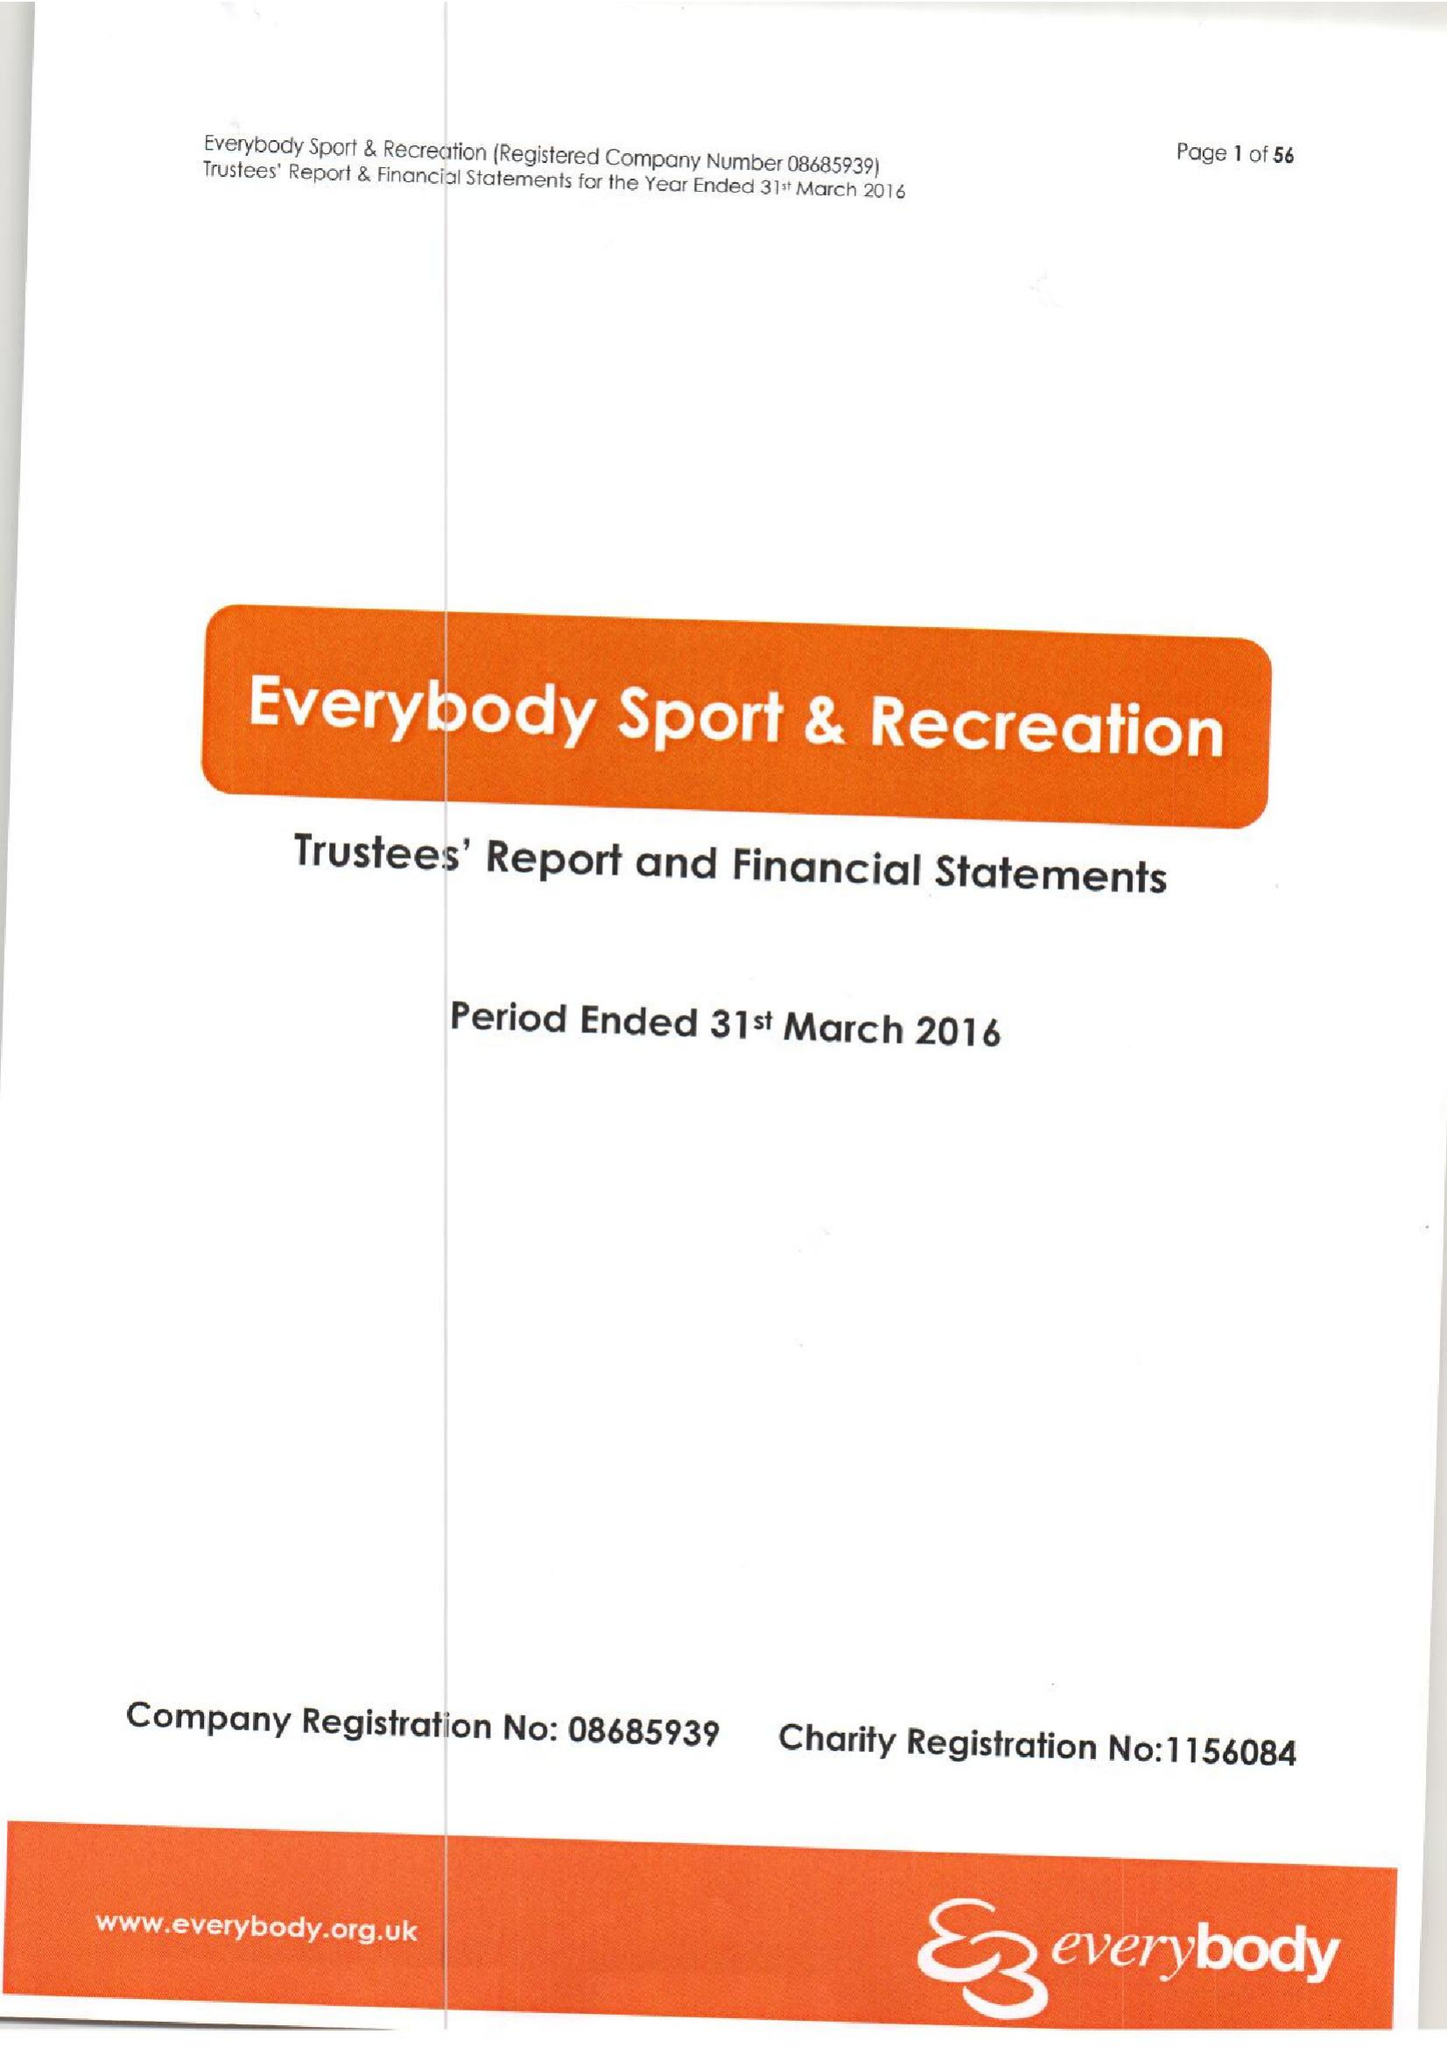What is the value for the charity_number?
Answer the question using a single word or phrase. 1156084 